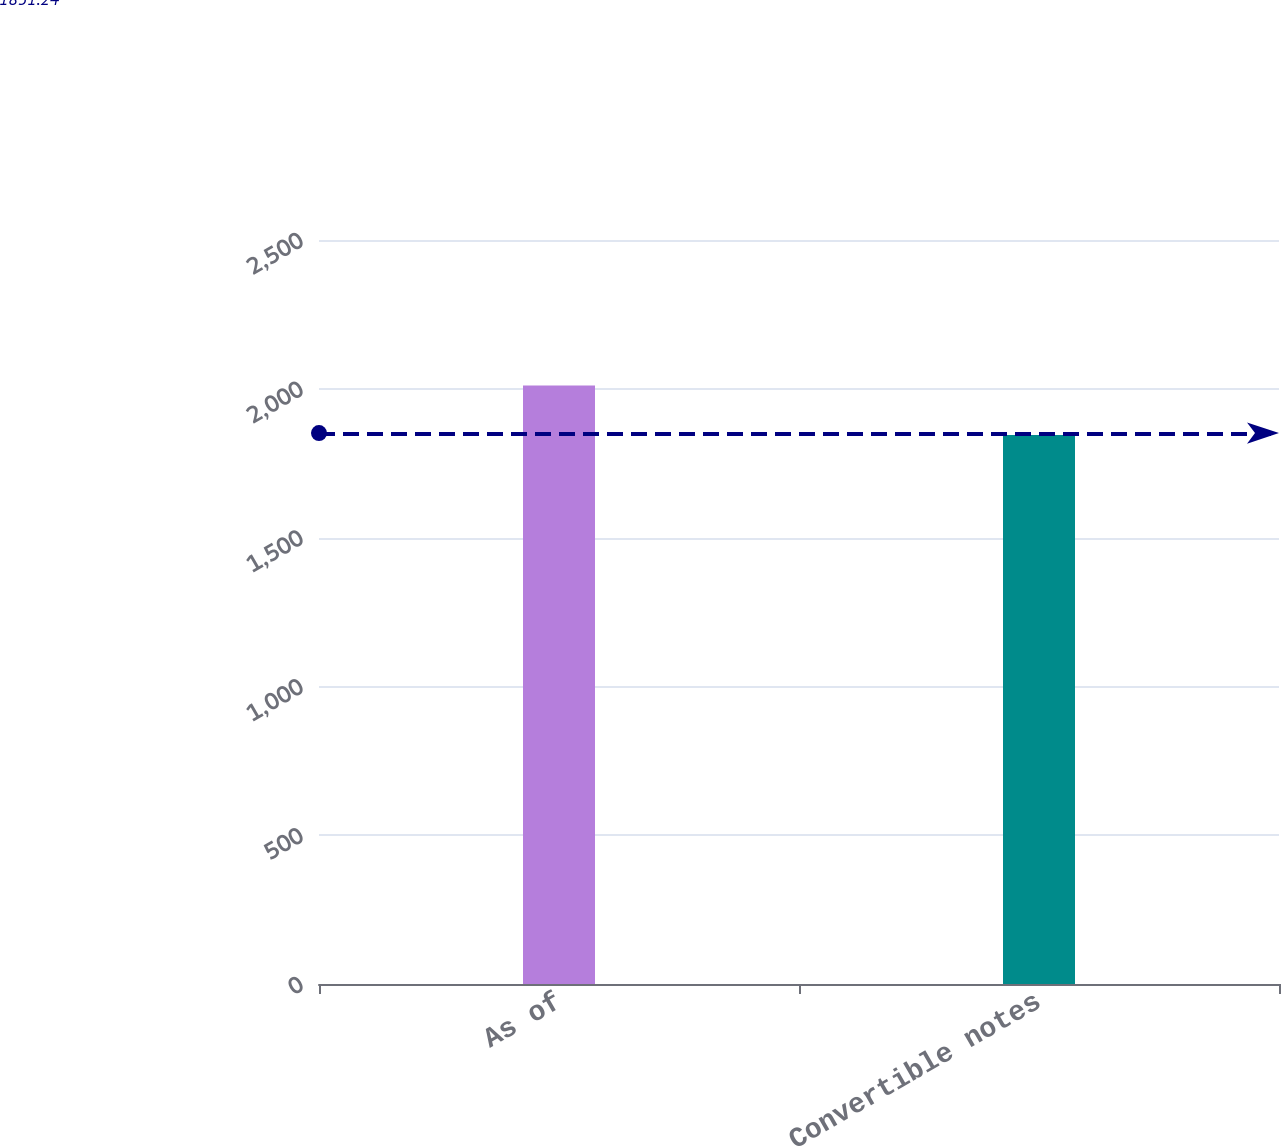<chart> <loc_0><loc_0><loc_500><loc_500><bar_chart><fcel>As of<fcel>Convertible notes<nl><fcel>2011<fcel>1845<nl></chart> 